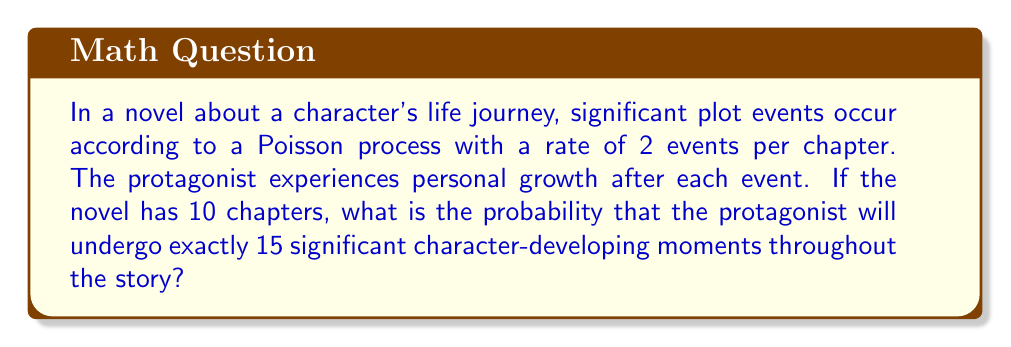Show me your answer to this math problem. To solve this problem, we'll use the Poisson distribution formula. The Poisson distribution is given by:

$$P(X = k) = \frac{e^{-\lambda} \lambda^k}{k!}$$

Where:
- $\lambda$ is the average number of events in the given interval
- $k$ is the number of events we're interested in
- $e$ is Euler's number (approximately 2.71828)

Step 1: Calculate $\lambda$ for the entire novel
- Rate of events per chapter = 2
- Number of chapters = 10
- $\lambda = 2 \times 10 = 20$

Step 2: Apply the Poisson distribution formula
- $k = 15$ (we want exactly 15 events)
- $\lambda = 20$

$$P(X = 15) = \frac{e^{-20} 20^{15}}{15!}$$

Step 3: Calculate the result
Using a calculator or computer:

$$P(X = 15) \approx 0.0516$$

This means there's approximately a 5.16% chance that the protagonist will experience exactly 15 significant character-developing moments throughout the 10-chapter novel.
Answer: $0.0516$ or $5.16\%$ 